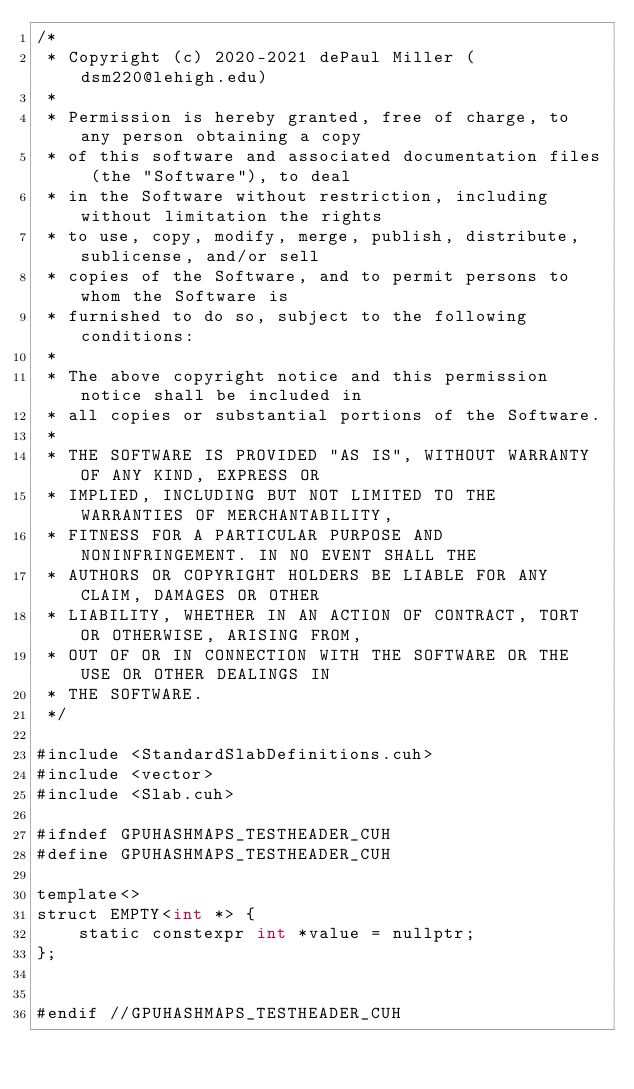Convert code to text. <code><loc_0><loc_0><loc_500><loc_500><_Cuda_>/*
 * Copyright (c) 2020-2021 dePaul Miller (dsm220@lehigh.edu)
 *
 * Permission is hereby granted, free of charge, to any person obtaining a copy
 * of this software and associated documentation files (the "Software"), to deal
 * in the Software without restriction, including without limitation the rights
 * to use, copy, modify, merge, publish, distribute, sublicense, and/or sell
 * copies of the Software, and to permit persons to whom the Software is
 * furnished to do so, subject to the following conditions:
 *
 * The above copyright notice and this permission notice shall be included in
 * all copies or substantial portions of the Software.
 *
 * THE SOFTWARE IS PROVIDED "AS IS", WITHOUT WARRANTY OF ANY KIND, EXPRESS OR
 * IMPLIED, INCLUDING BUT NOT LIMITED TO THE WARRANTIES OF MERCHANTABILITY,
 * FITNESS FOR A PARTICULAR PURPOSE AND NONINFRINGEMENT. IN NO EVENT SHALL THE
 * AUTHORS OR COPYRIGHT HOLDERS BE LIABLE FOR ANY CLAIM, DAMAGES OR OTHER
 * LIABILITY, WHETHER IN AN ACTION OF CONTRACT, TORT OR OTHERWISE, ARISING FROM,
 * OUT OF OR IN CONNECTION WITH THE SOFTWARE OR THE USE OR OTHER DEALINGS IN
 * THE SOFTWARE.
 */

#include <StandardSlabDefinitions.cuh>
#include <vector>
#include <Slab.cuh>

#ifndef GPUHASHMAPS_TESTHEADER_CUH
#define GPUHASHMAPS_TESTHEADER_CUH

template<>
struct EMPTY<int *> {
    static constexpr int *value = nullptr;
};


#endif //GPUHASHMAPS_TESTHEADER_CUH
</code> 